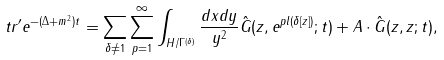<formula> <loc_0><loc_0><loc_500><loc_500>t r ^ { \prime } e ^ { - ( \Delta + m ^ { 2 } ) t } = \sum _ { \delta \neq 1 } \sum _ { p = 1 } ^ { \infty } \int _ { H / \Gamma ^ { ( \delta ) } } \frac { d x d y } { y ^ { 2 } } \hat { G } ( z , e ^ { p l ( \delta [ z ] ) } ; t ) + A \cdot \hat { G } ( z , z ; t ) ,</formula> 